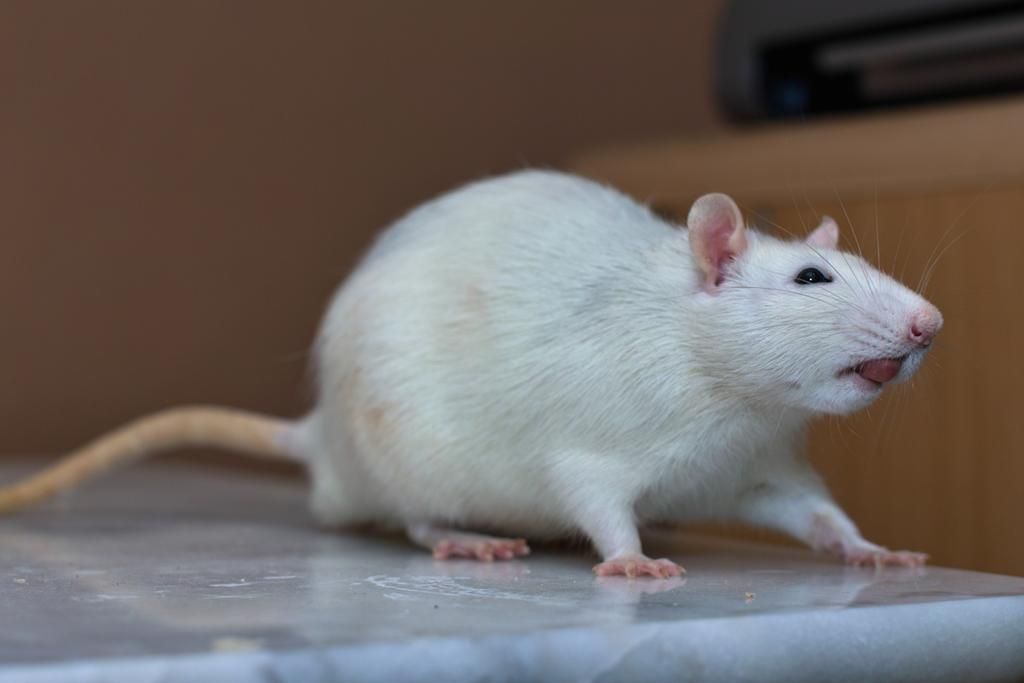What animal is present in the image? There is a rat in the image. Where is the rat located in the image? The rat is on the marble floor. Can you describe the background of the image? The background of the image is brown and blurred. What type of shelf can be seen in the image? There is no shelf present in the image. How does the rat react to the shock in the image? There is no shock or any indication of a shock in the image. 